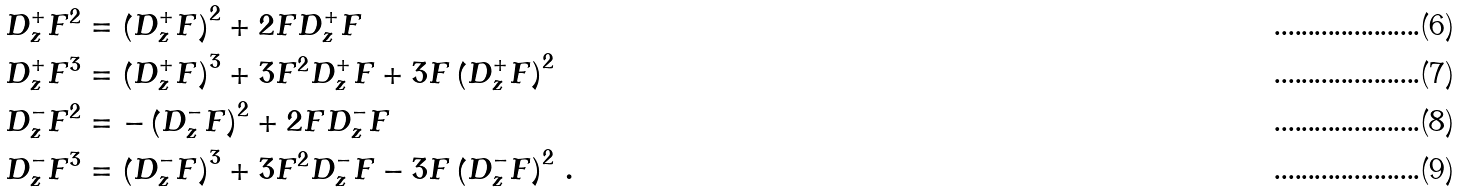<formula> <loc_0><loc_0><loc_500><loc_500>D ^ { + } _ { z } F ^ { 2 } & = \left ( D ^ { + } _ { z } F \right ) ^ { 2 } + 2 F D ^ { + } _ { z } F \\ D ^ { + } _ { z } F ^ { 3 } & = \left ( D ^ { + } _ { z } F \right ) ^ { 3 } + 3 F ^ { 2 } D ^ { + } _ { z } F + 3 F \left ( D ^ { + } _ { z } F \right ) ^ { 2 } \\ D ^ { - } _ { z } F ^ { 2 } & = - \left ( D ^ { - } _ { z } F \right ) ^ { 2 } + 2 F D _ { z } ^ { - } F \\ D ^ { - } _ { z } F ^ { 3 } & = \left ( D ^ { - } _ { z } F \right ) ^ { 3 } + 3 F ^ { 2 } D ^ { - } _ { z } F - 3 F \left ( D ^ { - } _ { z } F \right ) ^ { 2 } \, .</formula> 